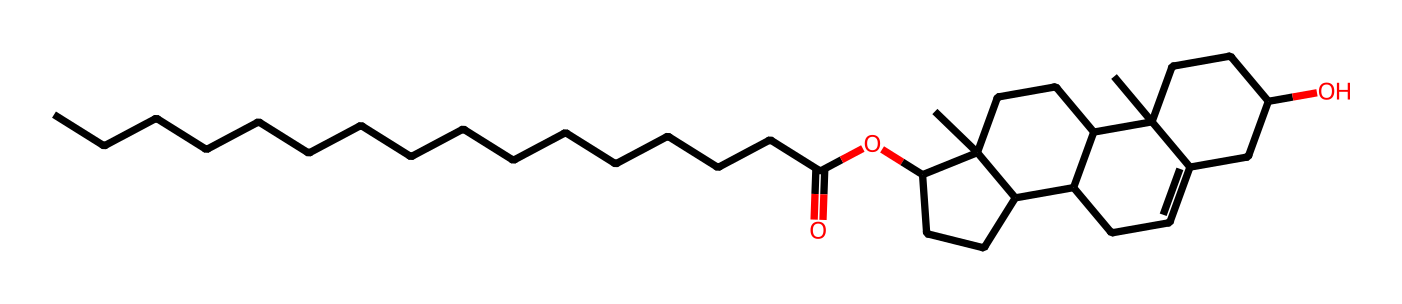What is the main functional group present in this chemical? Observing the SMILES notation, the presence of “OC” at the end indicates an ester functional group. This is because an ester is formed from the reaction of an alcohol and a carboxylic acid, which is consistent with the notation provided.
Answer: ester How many carbon atoms are in this molecule? By analyzing the SMILES representation, each “C” and the “CCCC...CC” sequence indicates carbon atoms. There is a total of 27 carbon atoms counted from the structure.
Answer: 27 What type of lipid is represented by this structure? The presence of fatty acid chains and an ester functional group suggests this is a wax. Waxes are lipids that consist of long-chain fatty acids linked to long-chain alcohols, commonly found in natural substances like lanolin from sheep wool.
Answer: wax What is the degree of unsaturation in this compound? To determine the degree of unsaturation (which indicates the number of rings or double bonds), we can use the formula: Degree of unsaturation = (2C + 2 + N - H - X) / 2. From the structure, there are 27 carbons and no nitrogen or halogens, making calculations confirm a degree of unsaturation of 6.
Answer: 6 Does this lipid contain any functional groups that suggest it may interact with water? Yes, the presence of the ester functional group as indicated by “OC” implies that it can form hydrogen bonds with water, making it amphipathic. This property allows interactions with both hydrophobic and hydrophilic environments.
Answer: yes How many rings can be identified in the structure? By carefully examining the structure and counting the cycloalkane parts indicated, there are 4 rings present in this molecule, which contributes to its three-dimensional conformation.
Answer: 4 